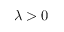<formula> <loc_0><loc_0><loc_500><loc_500>\lambda > 0</formula> 